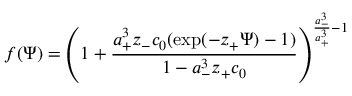<formula> <loc_0><loc_0><loc_500><loc_500>f ( \Psi ) = \left ( 1 + \frac { a _ { + } ^ { 3 } z _ { - } c _ { 0 } ( \exp ( - z _ { + } \Psi ) - 1 ) } { 1 - a _ { - } ^ { 3 } z _ { + } c _ { 0 } } \right ) ^ { \frac { a _ { - } ^ { 3 } } { a _ { + } ^ { 3 } } - 1 }</formula> 